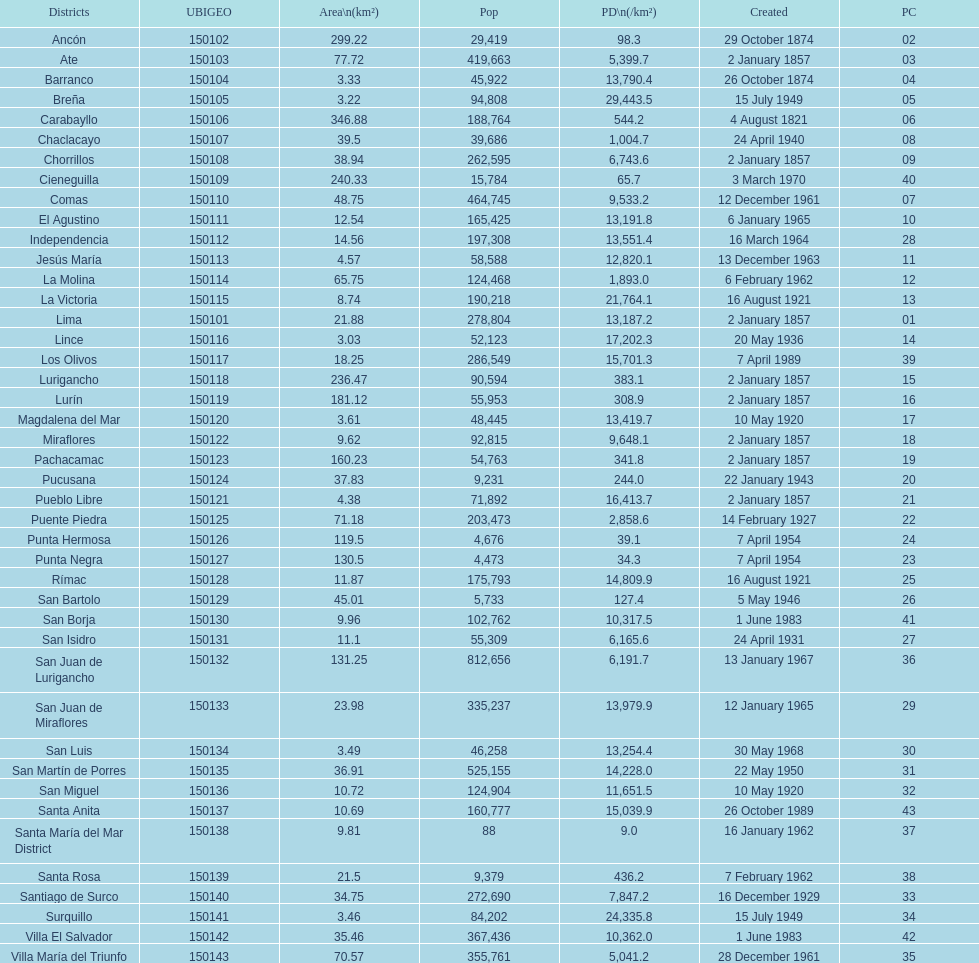How many districts have a population density of at lest 1000.0? 31. 